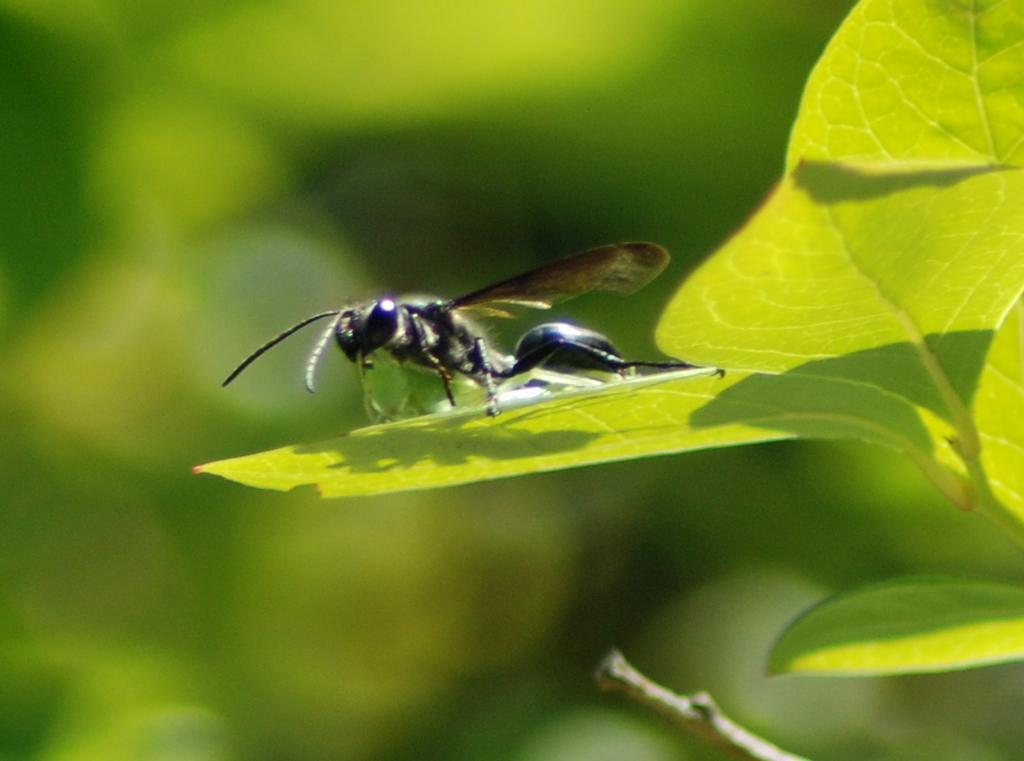How would you summarize this image in a sentence or two? In this image I can see an insect on the leaf. I can also see the background is green in color. 